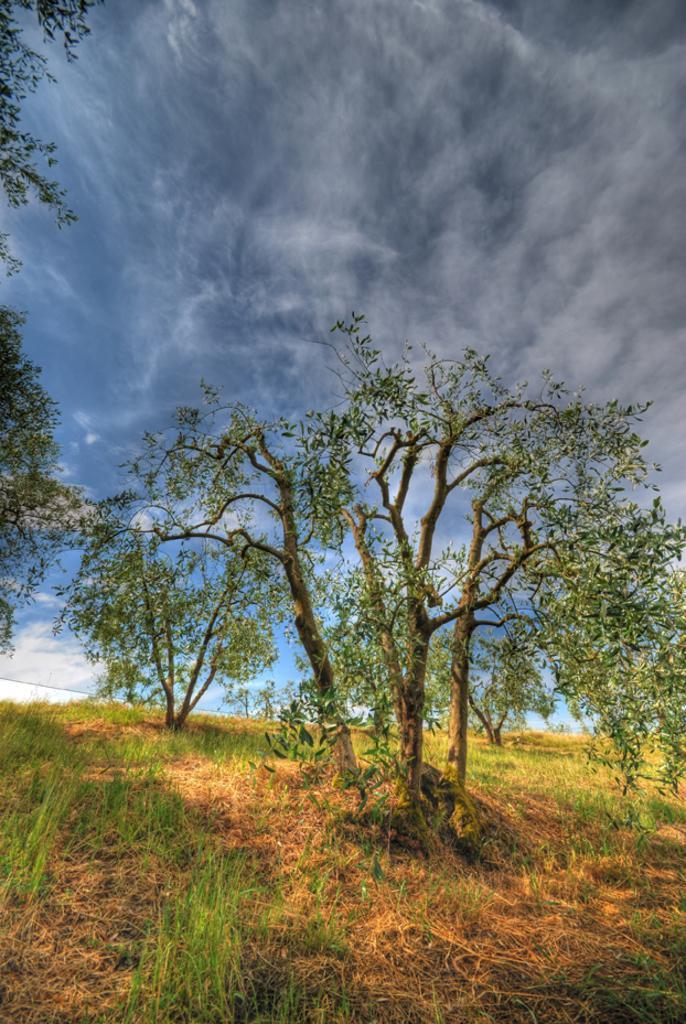How would you summarize this image in a sentence or two? There are trees and grass on the ground. In the background, there are clouds in the blue sky. 